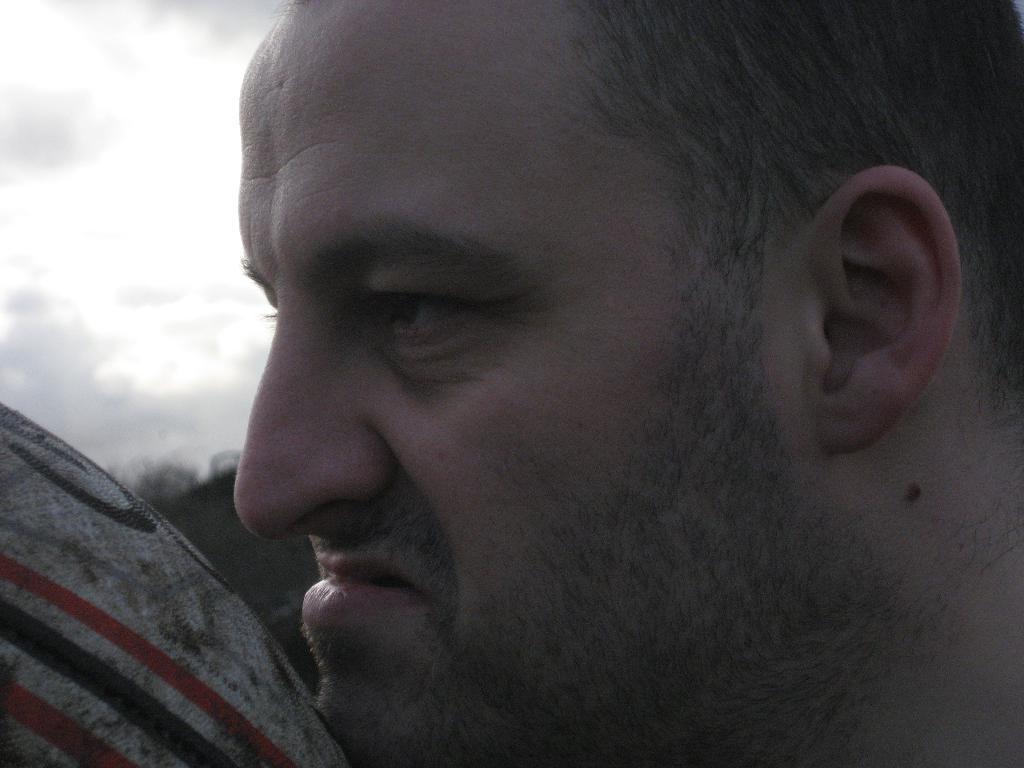Can you describe this image briefly? On the right side of the image we can see a person's head. On the left side of the image we can see the trees and the ball. In the top left corner we can see the clouds in the sky. 